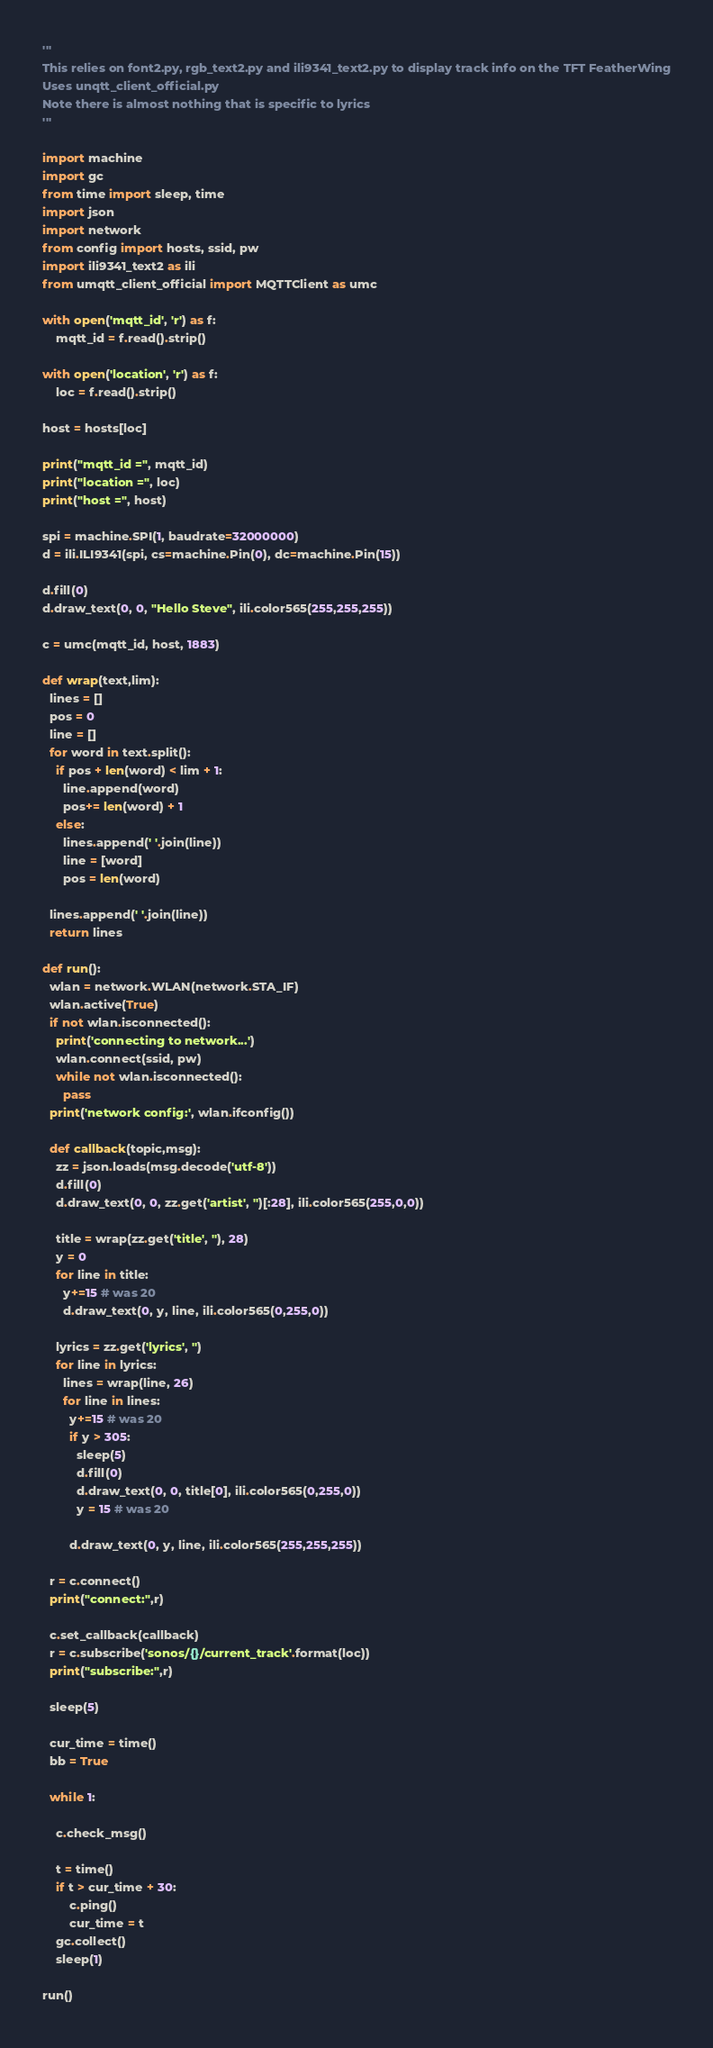<code> <loc_0><loc_0><loc_500><loc_500><_Python_>'''
This relies on font2.py, rgb_text2.py and ili9341_text2.py to display track info on the TFT FeatherWing
Uses unqtt_client_official.py
Note there is almost nothing that is specific to lyrics
'''

import machine
import gc
from time import sleep, time
import json
import network
from config import hosts, ssid, pw 
import ili9341_text2 as ili
from umqtt_client_official import MQTTClient as umc

with open('mqtt_id', 'r') as f:
    mqtt_id = f.read().strip()

with open('location', 'r') as f:
    loc = f.read().strip()

host = hosts[loc]

print("mqtt_id =", mqtt_id)
print("location =", loc)
print("host =", host)

spi = machine.SPI(1, baudrate=32000000)
d = ili.ILI9341(spi, cs=machine.Pin(0), dc=machine.Pin(15))

d.fill(0)
d.draw_text(0, 0, "Hello Steve", ili.color565(255,255,255))

c = umc(mqtt_id, host, 1883)

def wrap(text,lim):
  lines = []
  pos = 0 
  line = []
  for word in text.split():
    if pos + len(word) < lim + 1:
      line.append(word)
      pos+= len(word) + 1 
    else:
      lines.append(' '.join(line))
      line = [word] 
      pos = len(word)

  lines.append(' '.join(line))
  return lines

def run():
  wlan = network.WLAN(network.STA_IF)
  wlan.active(True)
  if not wlan.isconnected():
    print('connecting to network...')
    wlan.connect(ssid, pw)
    while not wlan.isconnected():
      pass
  print('network config:', wlan.ifconfig())     

  def callback(topic,msg):
    zz = json.loads(msg.decode('utf-8'))
    d.fill(0)
    d.draw_text(0, 0, zz.get('artist', '')[:28], ili.color565(255,0,0)) 

    title = wrap(zz.get('title', ''), 28)
    y = 0 
    for line in title:
      y+=15 # was 20
      d.draw_text(0, y, line, ili.color565(0,255,0))

    lyrics = zz.get('lyrics', '')
    for line in lyrics:
      lines = wrap(line, 26)
      for line in lines:
        y+=15 # was 20
        if y > 305:
          sleep(5)
          d.fill(0)
          d.draw_text(0, 0, title[0], ili.color565(0,255,0))
          y = 15 # was 20

        d.draw_text(0, y, line, ili.color565(255,255,255))

  r = c.connect()
  print("connect:",r)

  c.set_callback(callback)
  r = c.subscribe('sonos/{}/current_track'.format(loc))
  print("subscribe:",r)

  sleep(5) 

  cur_time = time()
  bb = True

  while 1:

    c.check_msg()
    
    t = time()
    if t > cur_time + 30:
        c.ping()
        cur_time = t
    gc.collect()
    sleep(1)

run()
</code> 